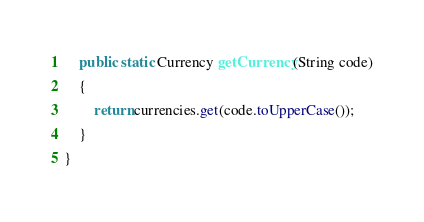Convert code to text. <code><loc_0><loc_0><loc_500><loc_500><_Java_>	public static Currency getCurrency(String code)
	{
		return currencies.get(code.toUpperCase());
	}
}
</code> 